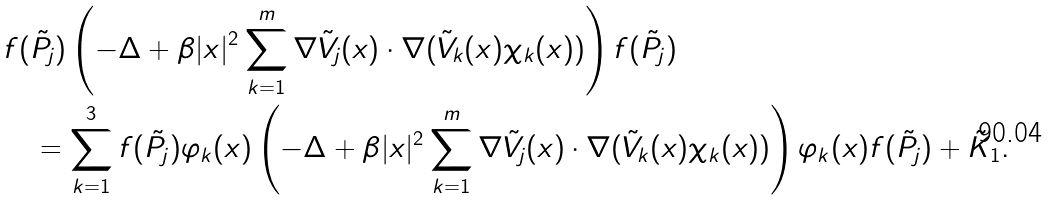<formula> <loc_0><loc_0><loc_500><loc_500>& f ( \tilde { P } _ { j } ) \left ( - \Delta + \beta | x | ^ { 2 } \sum _ { k = 1 } ^ { m } \nabla \tilde { V } _ { j } ( x ) \cdot \nabla ( \tilde { V } _ { k } ( x ) \chi _ { k } ( x ) ) \right ) f ( \tilde { P } _ { j } ) \\ & \quad = \sum _ { k = 1 } ^ { 3 } f ( \tilde { P } _ { j } ) \varphi _ { k } ( x ) \left ( - \Delta + \beta | x | ^ { 2 } \sum _ { k = 1 } ^ { m } \nabla \tilde { V } _ { j } ( x ) \cdot \nabla ( \tilde { V } _ { k } ( x ) \chi _ { k } ( x ) ) \right ) \varphi _ { k } ( x ) f ( \tilde { P } _ { j } ) + \tilde { K } _ { 1 } .</formula> 